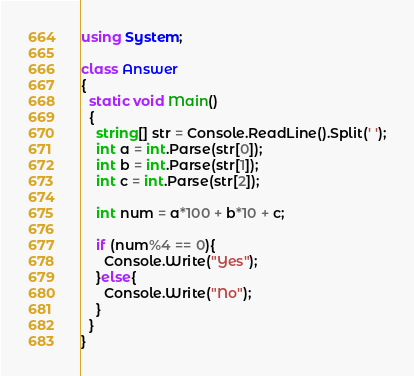<code> <loc_0><loc_0><loc_500><loc_500><_C#_>using System;

class Answer
{
  static void Main()
  {
    string[] str = Console.ReadLine().Split(' ');
    int a = int.Parse(str[0]);
    int b = int.Parse(str[1]);
    int c = int.Parse(str[2]);

    int num = a*100 + b*10 + c;

    if (num%4 == 0){
      Console.Write("Yes");
    }else{
      Console.Write("No");
    }
  }
}
</code> 